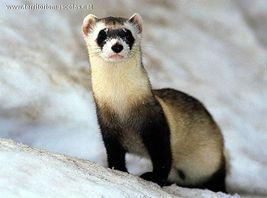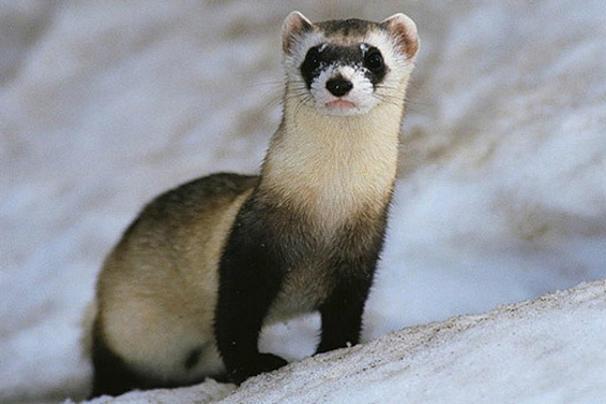The first image is the image on the left, the second image is the image on the right. For the images displayed, is the sentence "There are two weasels that have black and white coloring." factually correct? Answer yes or no. Yes. The first image is the image on the left, the second image is the image on the right. Given the left and right images, does the statement "at least one ferret is standing on the dirt with tufts of grass around it in the image pair" hold true? Answer yes or no. No. 